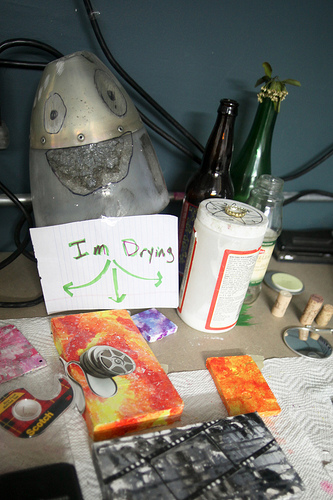<image>
Can you confirm if the bottle is next to the cork? No. The bottle is not positioned next to the cork. They are located in different areas of the scene. 